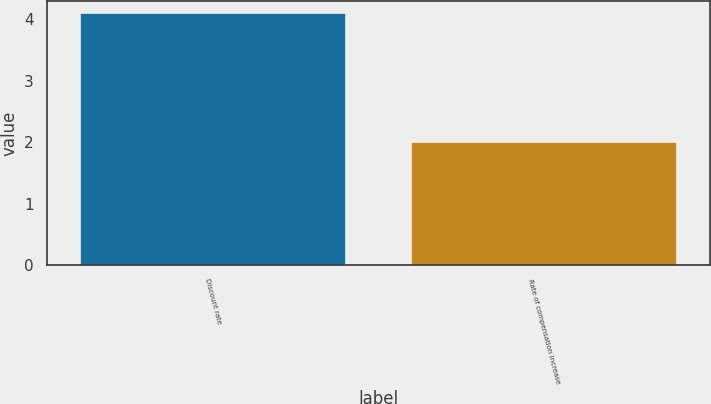Convert chart to OTSL. <chart><loc_0><loc_0><loc_500><loc_500><bar_chart><fcel>Discount rate<fcel>Rate of compensation increase<nl><fcel>4.1<fcel>2<nl></chart> 